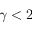<formula> <loc_0><loc_0><loc_500><loc_500>\gamma < 2</formula> 